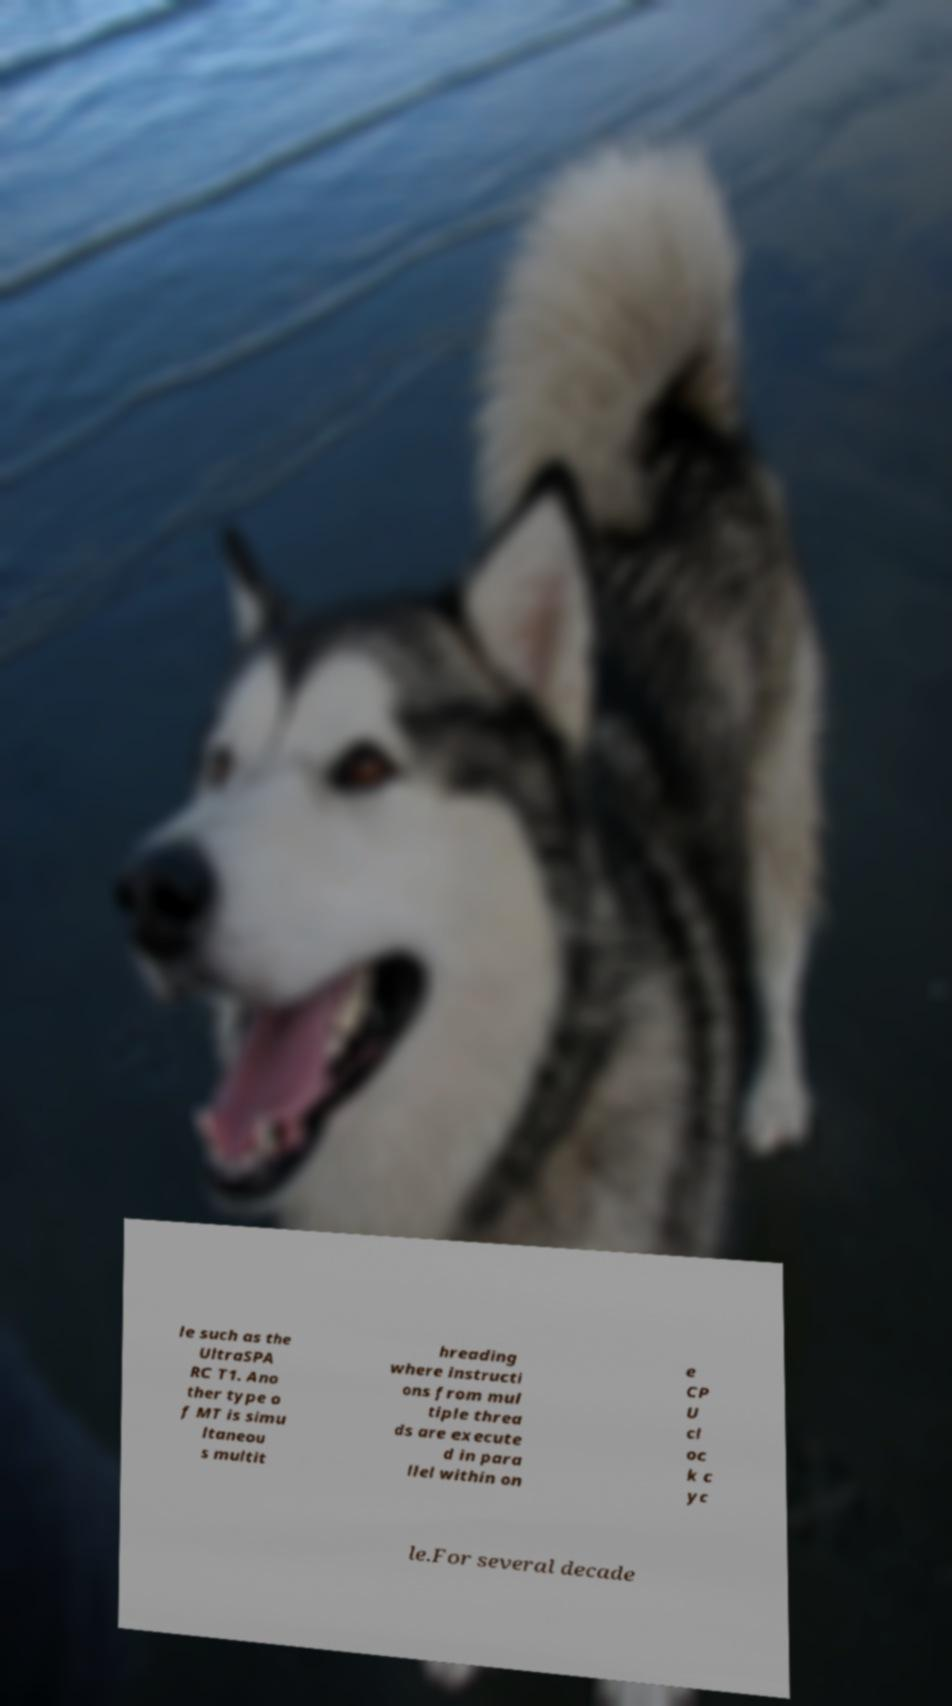What messages or text are displayed in this image? I need them in a readable, typed format. le such as the UltraSPA RC T1. Ano ther type o f MT is simu ltaneou s multit hreading where instructi ons from mul tiple threa ds are execute d in para llel within on e CP U cl oc k c yc le.For several decade 